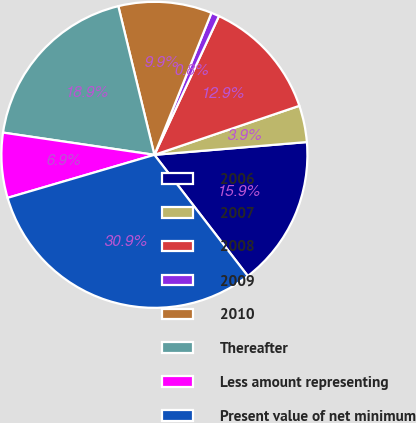Convert chart. <chart><loc_0><loc_0><loc_500><loc_500><pie_chart><fcel>2006<fcel>2007<fcel>2008<fcel>2009<fcel>2010<fcel>Thereafter<fcel>Less amount representing<fcel>Present value of net minimum<nl><fcel>15.88%<fcel>3.86%<fcel>12.88%<fcel>0.85%<fcel>9.87%<fcel>18.89%<fcel>6.86%<fcel>30.92%<nl></chart> 